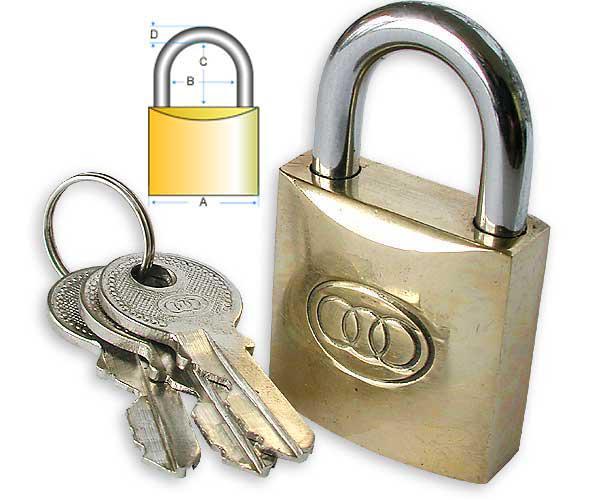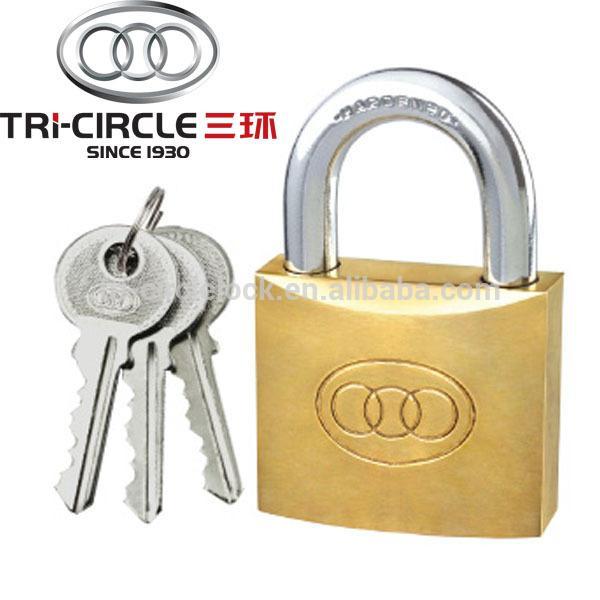The first image is the image on the left, the second image is the image on the right. For the images shown, is this caption "There are exactly six keys." true? Answer yes or no. Yes. The first image is the image on the left, the second image is the image on the right. For the images shown, is this caption "Each image contains exactly three keys and only gold-bodied locks." true? Answer yes or no. Yes. 